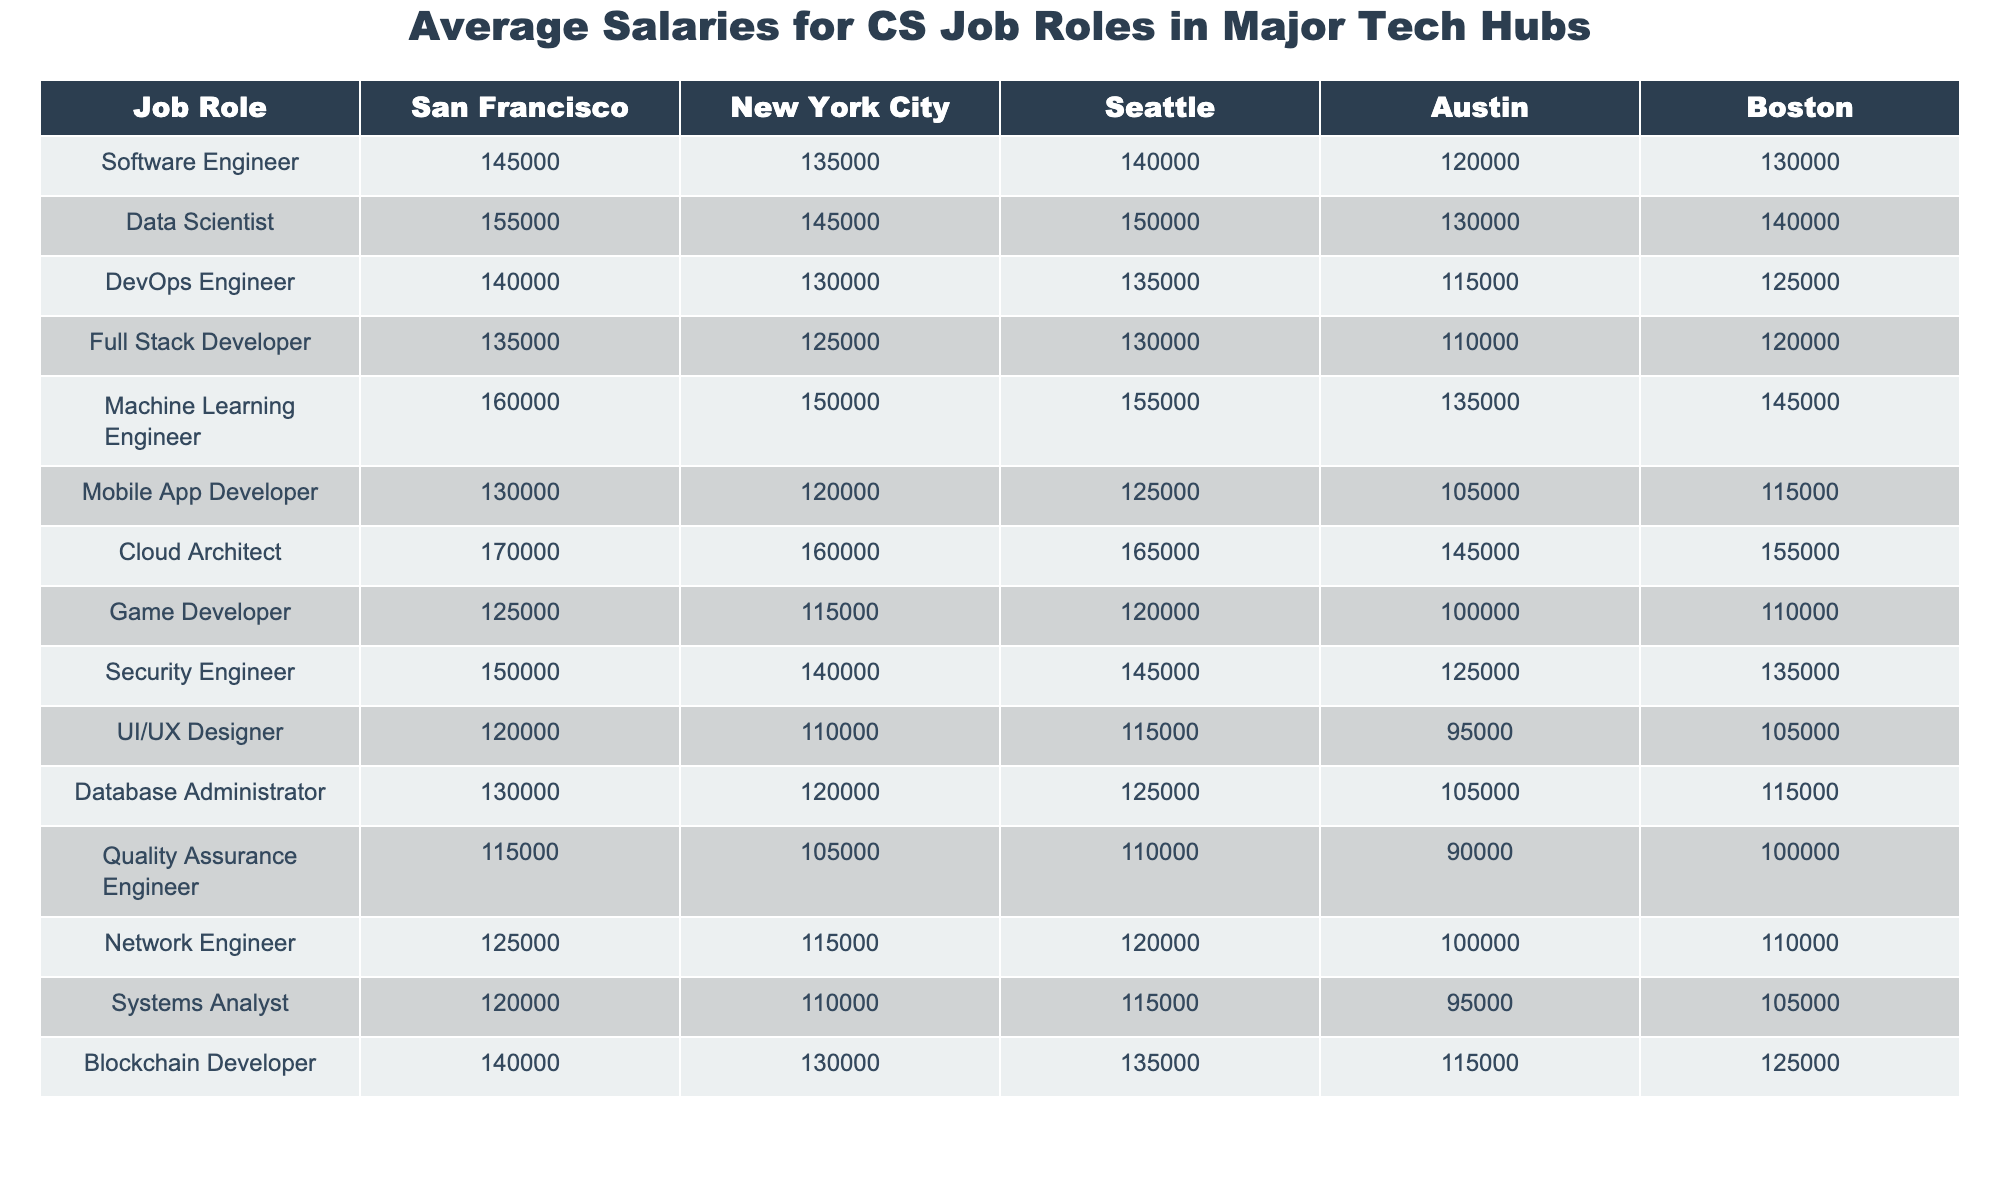What is the salary of a Data Scientist in Seattle? The table shows the salary of a Data Scientist under the Seattle column. The value listed there is 150,000.
Answer: 150,000 Which city offers the highest salary for a Cloud Architect? By comparing the salaries listed under the Cloud Architect row, San Francisco shows the highest figure at 170,000.
Answer: San Francisco What is the difference in salary between a Software Engineer in San Francisco and a Full Stack Developer in Austin? The salary for a Software Engineer in San Francisco is 145,000, and for a Full Stack Developer in Austin it is 110,000. The difference is 145,000 - 110,000 = 35,000.
Answer: 35,000 Is the salary of a Machine Learning Engineer higher in Boston than that of a Security Engineer in Seattle? The salary of a Machine Learning Engineer in Boston is 145,000, while the Security Engineer's salary in Seattle is 145,000 as well. Since they are equal, the answer is no.
Answer: No What is the average salary of a Mobile App Developer across all cities? To find the average salary, add the salaries listed for the Mobile App Developer across all cities: 130,000 + 120,000 + 125,000 + 105,000 + 115,000 = 595,000. Divide by the number of cities (5), which gives 595,000 / 5 = 119,000.
Answer: 119,000 Which job role has the lowest average salary across all cities? First, we find the average salary for each job role. By calculating these, we determine that the Game Developer has the lowest average salary (usually computed as the lowest value in the row). Its highest listed salary is only 125,000.
Answer: Game Developer What is the total salary for a Security Engineer across all listed cities? To find the total salary, add up the values in the Security Engineer's row: 150,000 + 140,000 + 145,000 + 125,000 + 135,000 = 695,000.
Answer: 695,000 In which city does the average salary for a Full Stack Developer exceed 120,000? Reviewing the salaries for Full Stack Developers, only San Francisco (135,000) and Seattle (130,000) exceed 120,000. Therefore, two cities meet this criterion.
Answer: San Francisco and Seattle What is the median salary for a Database Administrator among the listed cities? The salaries for a Database Administrator are 130,000, 120,000, 125,000, 105,000, and 115,000. Arranging these values gives 105,000, 115,000, 120,000, 125,000, 130,000. The median is the middle value, which is 120,000.
Answer: 120,000 Does a UI/UX Designer make more than a Network Engineer in New York City? The salary for a UI/UX Designer in New York City is 110,000, and for a Network Engineer, it is also 115,000. Since 110,000 is less than 115,000, the answer is no.
Answer: No 